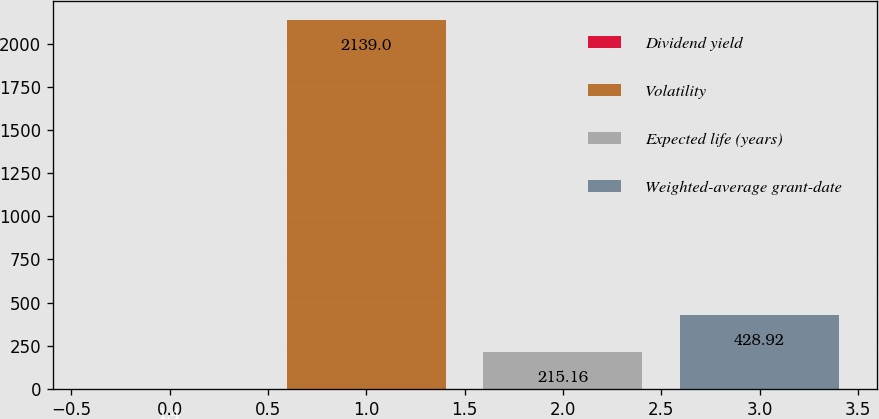Convert chart. <chart><loc_0><loc_0><loc_500><loc_500><bar_chart><fcel>Dividend yield<fcel>Volatility<fcel>Expected life (years)<fcel>Weighted-average grant-date<nl><fcel>1.4<fcel>2139<fcel>215.16<fcel>428.92<nl></chart> 